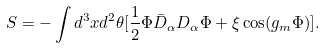Convert formula to latex. <formula><loc_0><loc_0><loc_500><loc_500>S = - \int d ^ { 3 } x d ^ { 2 } \theta [ \frac { 1 } { 2 } \Phi \bar { D } _ { \alpha } D _ { \alpha } \Phi + \xi \cos ( g _ { m } \Phi ) ] .</formula> 